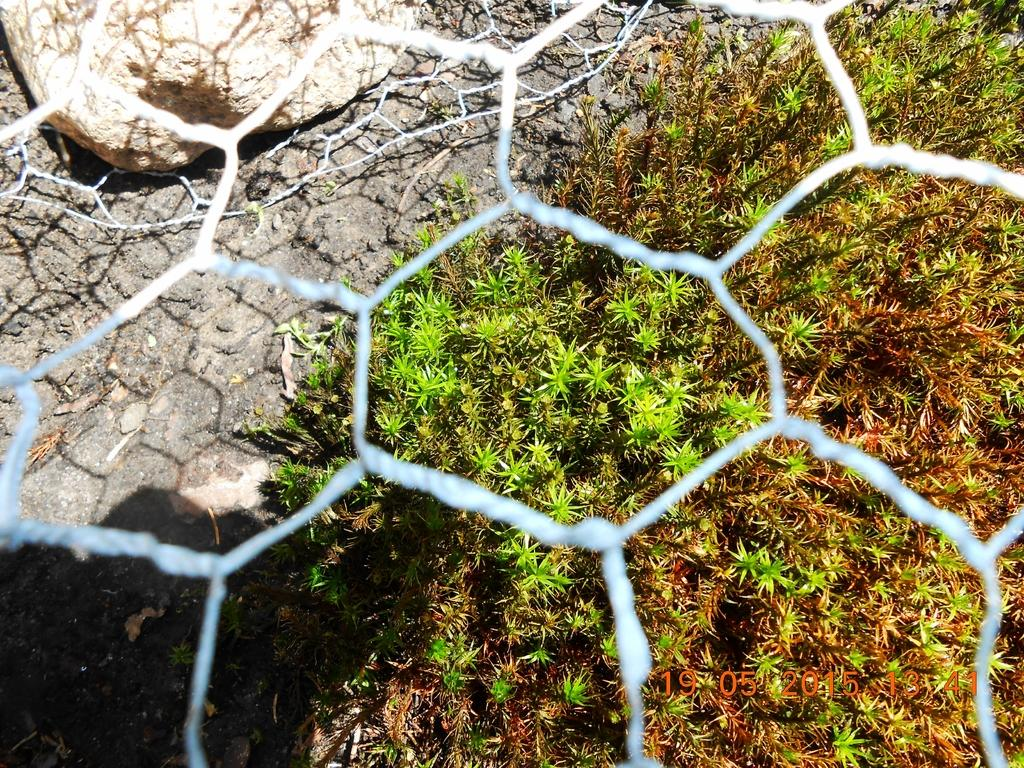What is the main feature of the image? The main feature of the image is a mesh. What can be seen through the mesh? Plants are visible through the mesh. Where are the plants located? The plants are on the ground. What other object is present in the image? There is a rock in the image. What is the price of the fruit hanging from the mesh in the image? There is no fruit hanging from the mesh in the image, so it is not possible to determine its price. 